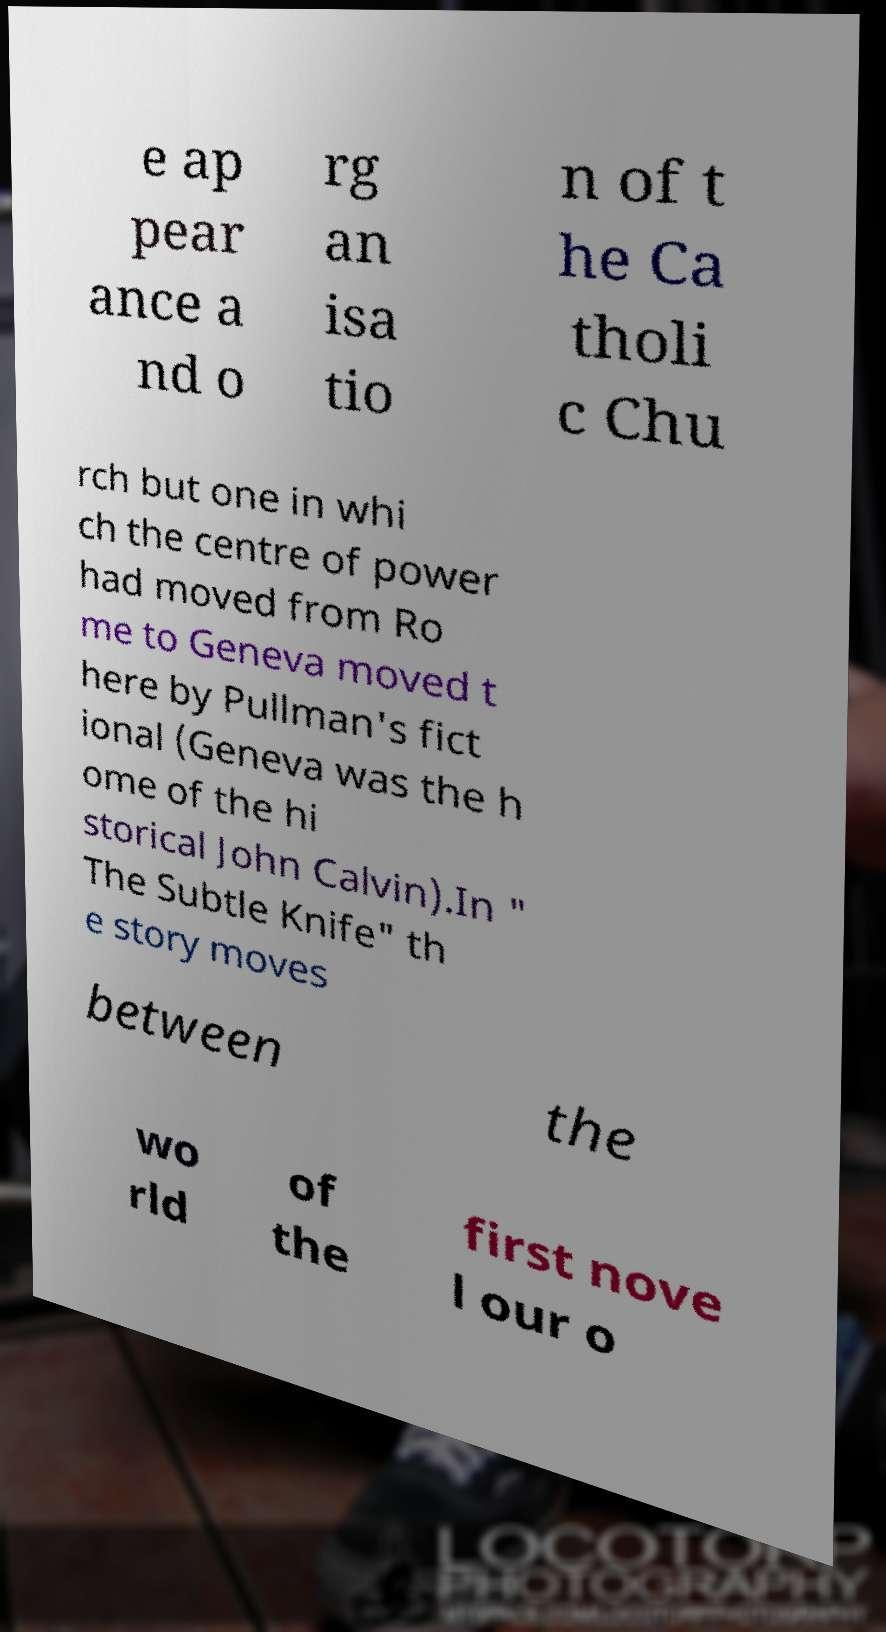Please read and relay the text visible in this image. What does it say? e ap pear ance a nd o rg an isa tio n of t he Ca tholi c Chu rch but one in whi ch the centre of power had moved from Ro me to Geneva moved t here by Pullman's fict ional (Geneva was the h ome of the hi storical John Calvin).In " The Subtle Knife" th e story moves between the wo rld of the first nove l our o 